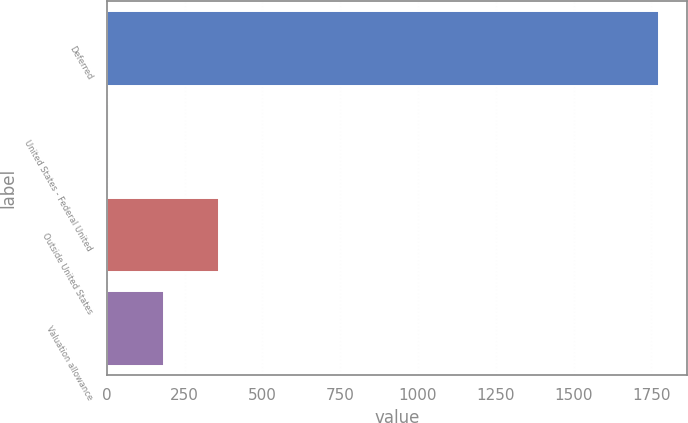Convert chart. <chart><loc_0><loc_0><loc_500><loc_500><bar_chart><fcel>Deferred<fcel>United States - Federal United<fcel>Outside United States<fcel>Valuation allowance<nl><fcel>1776<fcel>7<fcel>360.8<fcel>183.9<nl></chart> 